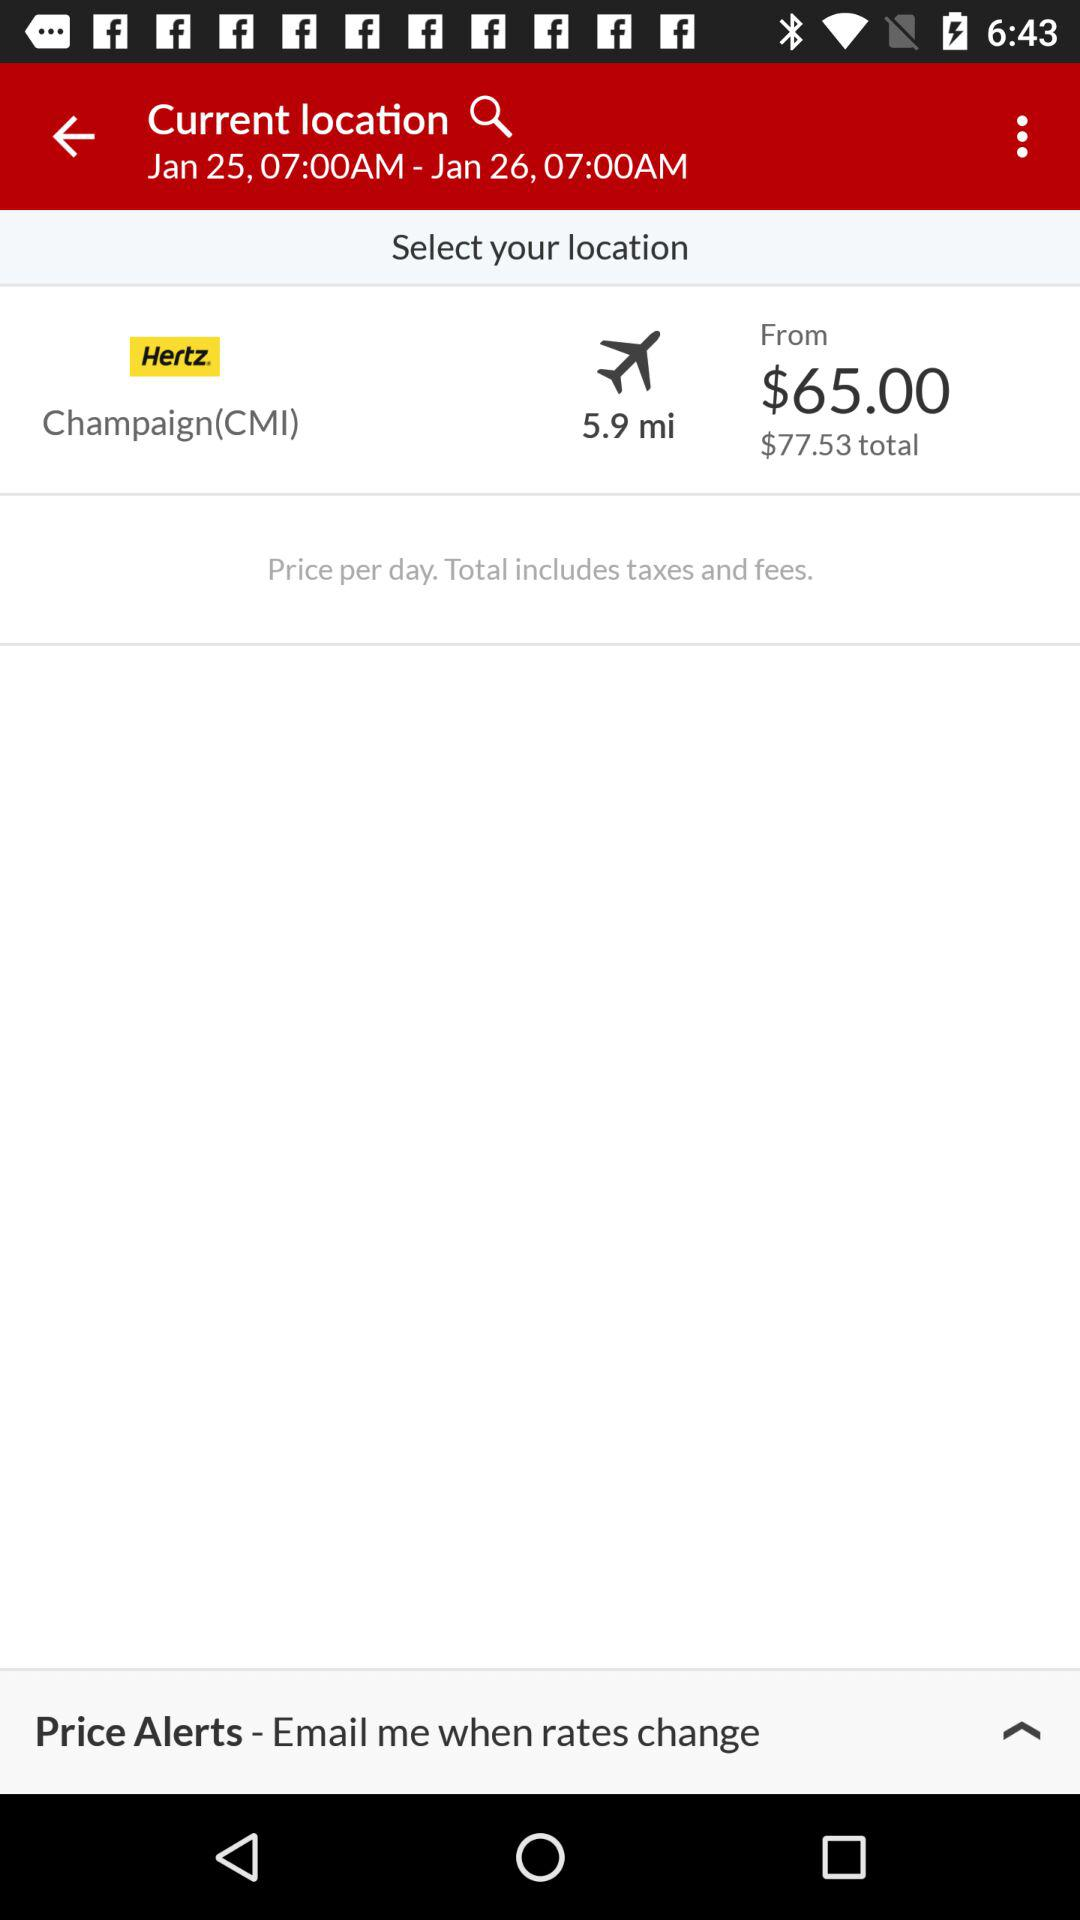What is the date and time? The date and time range from January 25 at 7:00 a.m. to January 26 at 7:00 a.m. 